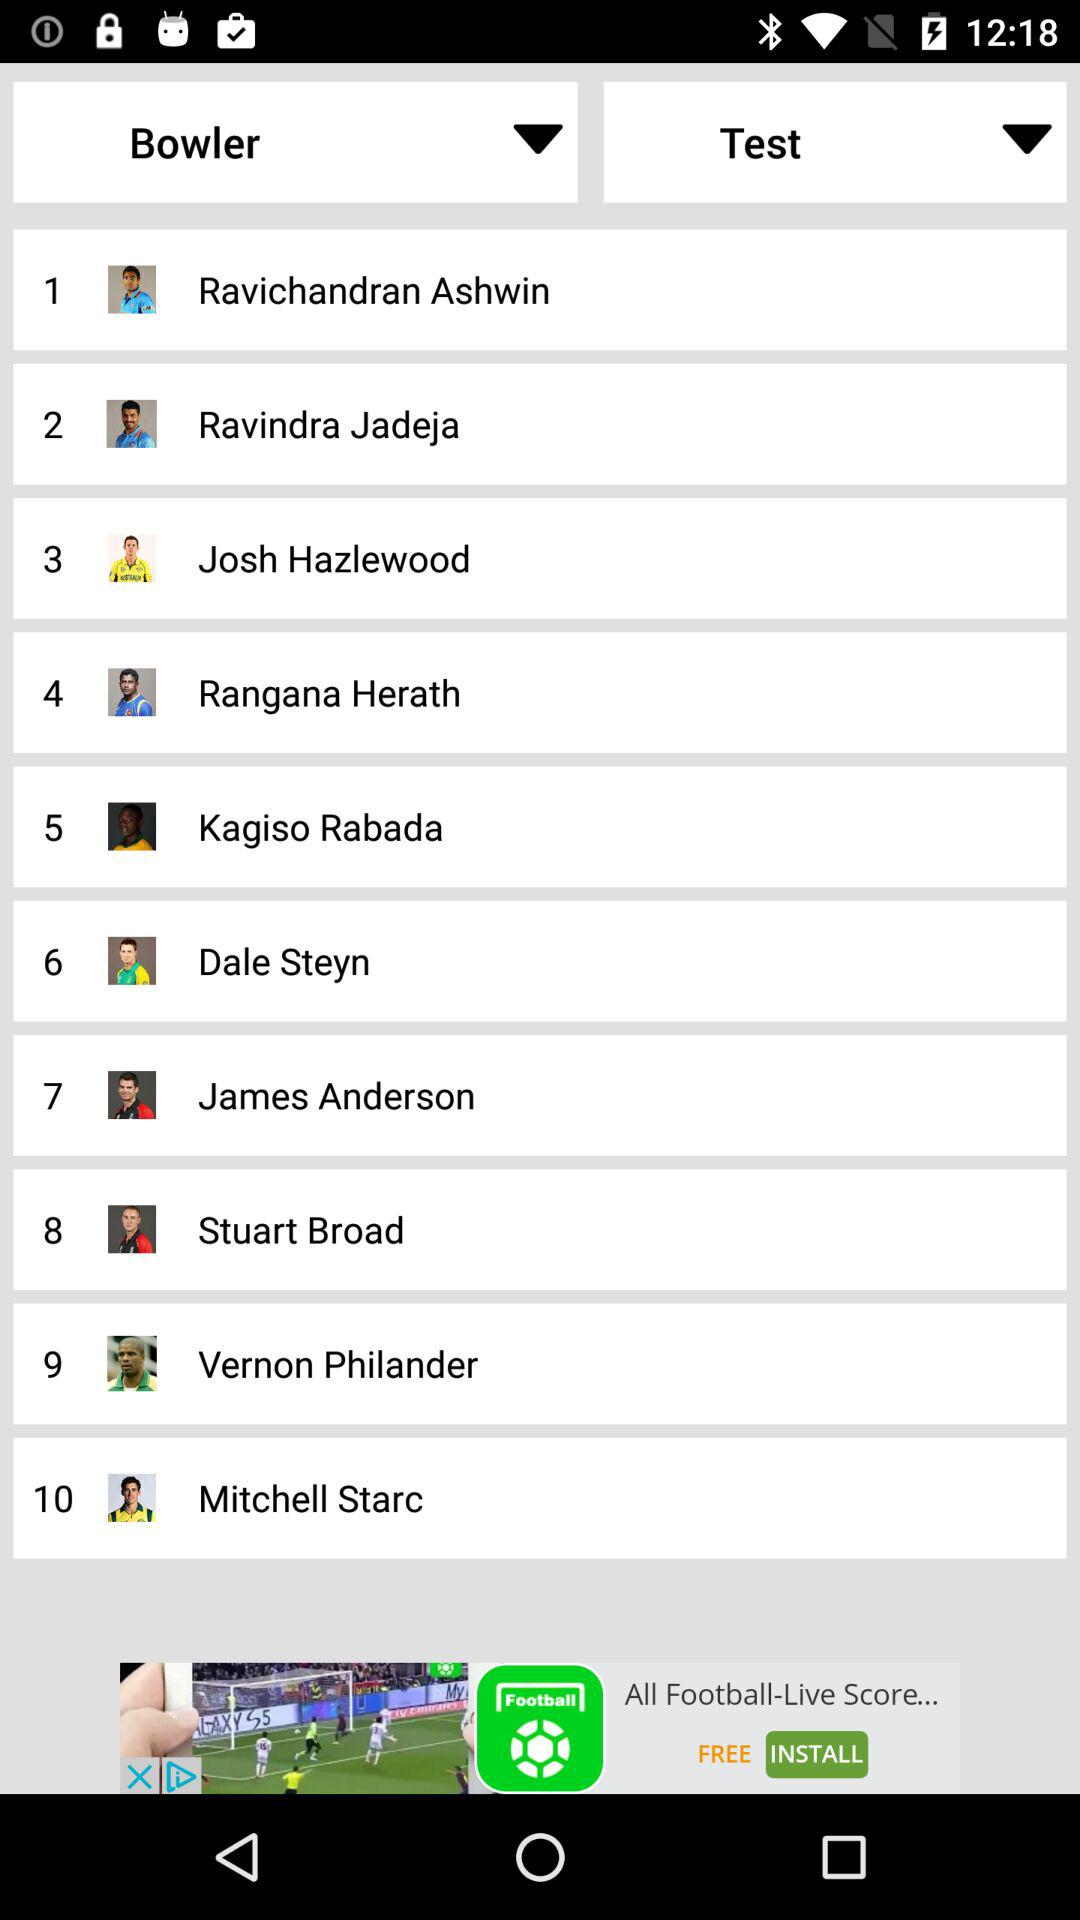How many bowlers have a green shirt?
Answer the question using a single word or phrase. 2 